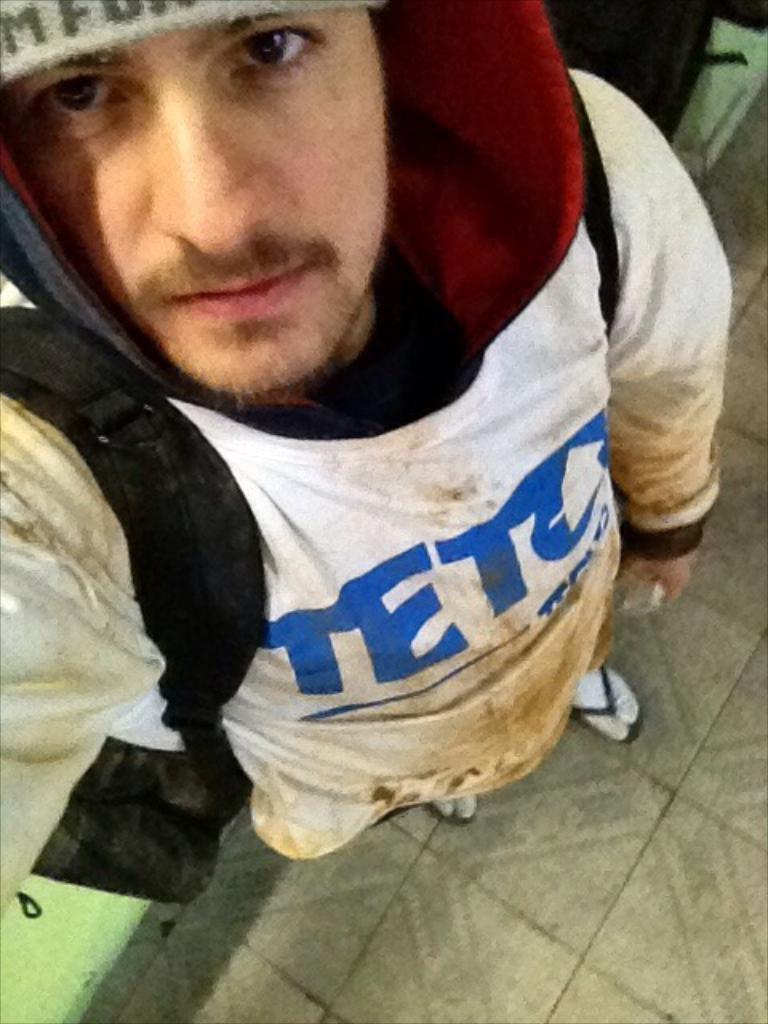Who does this man likely work for?
Your response must be concise. Teto. 